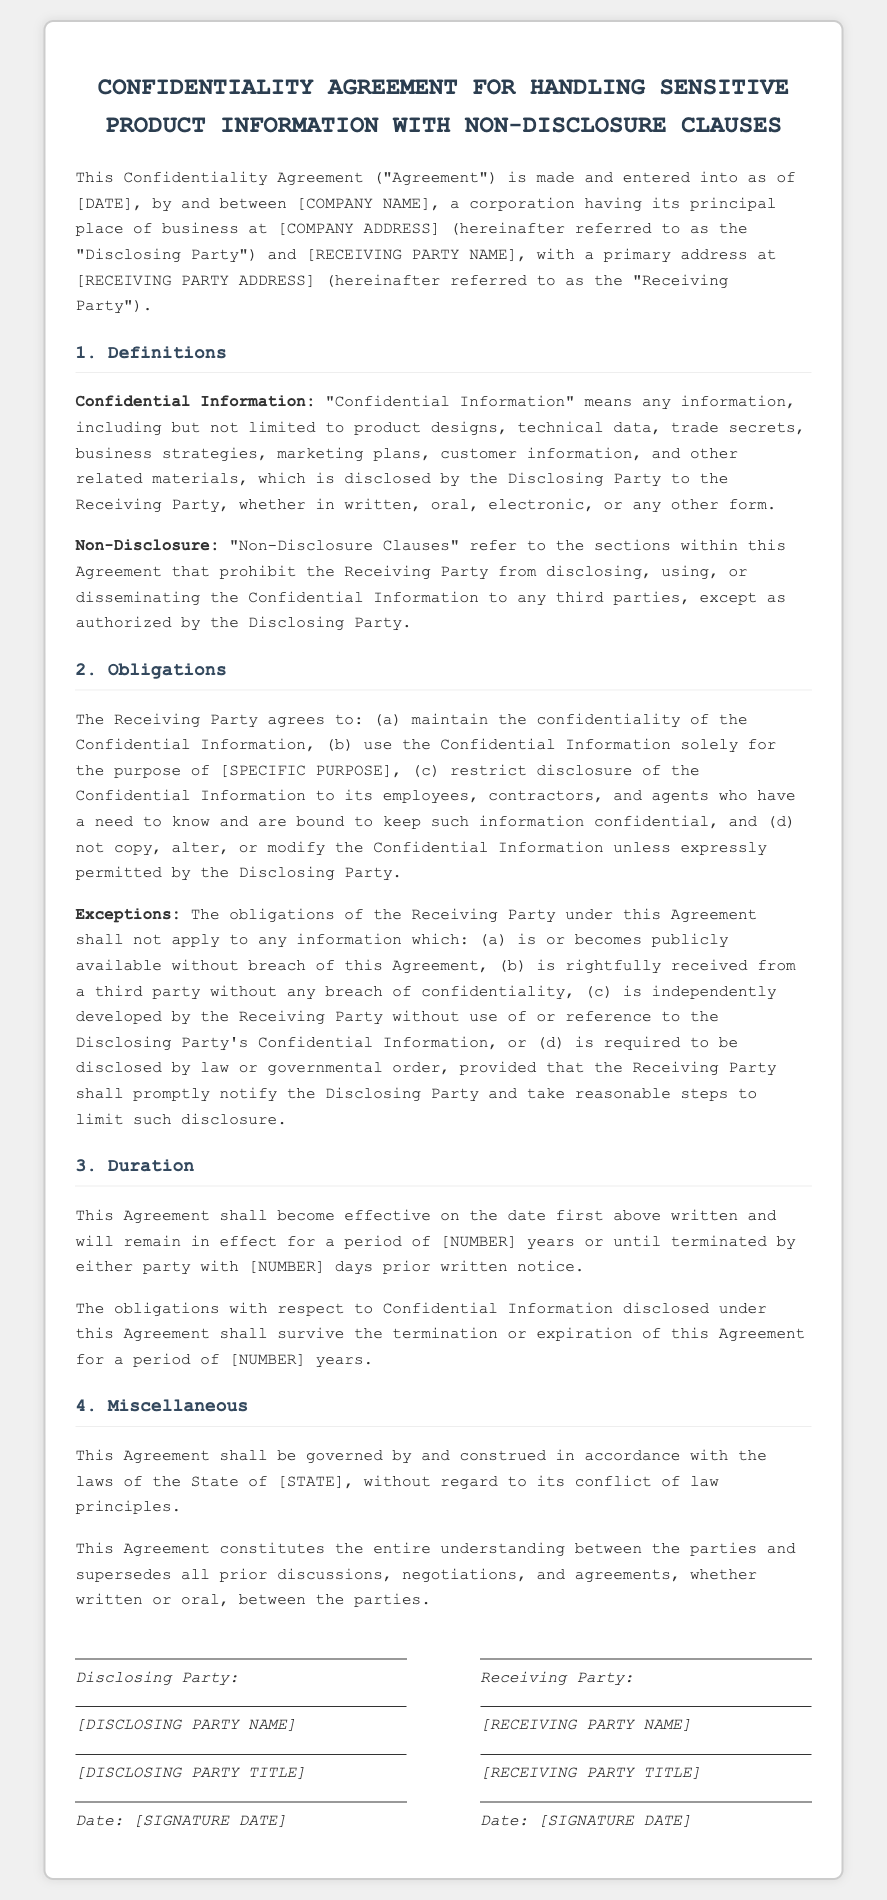What is the title of the document? The title is found in the heading of the document, emphasizing the nature of the agreement.
Answer: Confidentiality Agreement for Handling Sensitive Product Information with Non-Disclosure Clauses Who are the parties involved in the agreement? The parties involved are specified in the introductory paragraph of the document.
Answer: [COMPANY NAME] and [RECEIVING PARTY NAME] What does "Confidential Information" include? The definition of Confidential Information lists various types of information included in this category.
Answer: product designs, technical data, trade secrets, business strategies, marketing plans, customer information What is the duration of the confidentiality obligations? The duration is specified in the section related to the effective period and termination of the agreement.
Answer: [NUMBER] years What are the exceptions to the Receiving Party's obligations? The exceptions section highlights specific circumstances under which the obligations do not apply.
Answer: publicly available, rightfully received, independently developed, required by law What state governs this Agreement? The governing state is mentioned in the miscellaneous section of the document, ensuring legal understanding is aligned.
Answer: [STATE] What must the Receiving Party do upon receiving information required to be disclosed by law? This obligation is detailed in the exception clause relating to disclosures required by law.
Answer: promptly notify the Disclosing Party How many days notice is required for termination? The notice period for termination is found within the duration section of the contract.
Answer: [NUMBER] days 